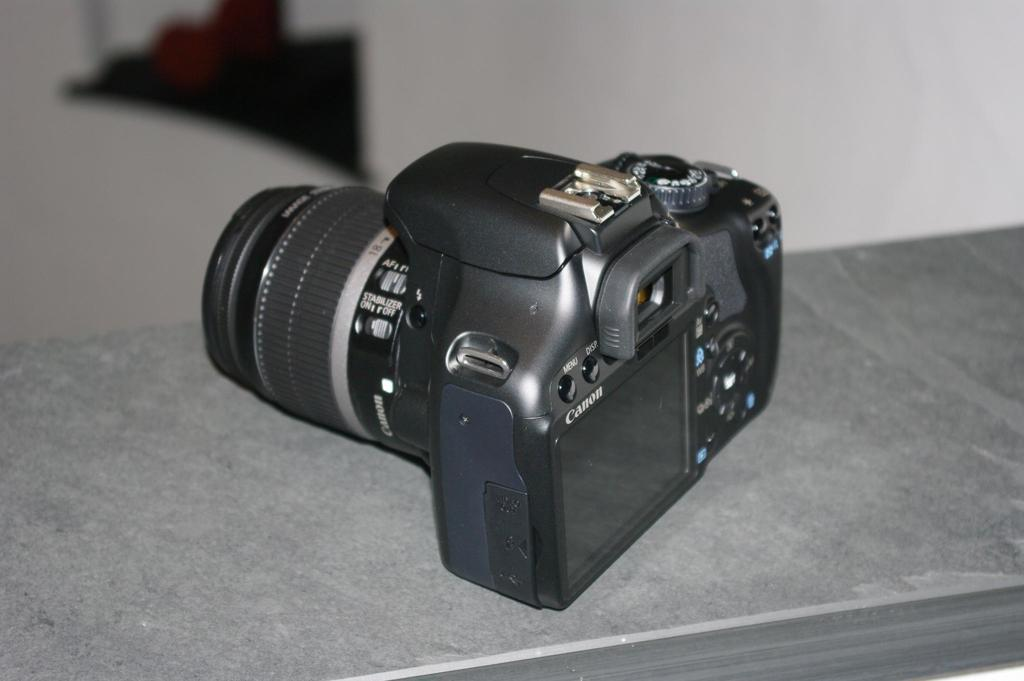What object is the main subject of the image? There is a camera in the image. What color is the camera? The camera is black in color. Are there any words or letters on the camera? Yes, there is text written on the camera. How many daughters can be seen working in the fields in the image? There are no daughters or fields present in the image; it features a black camera with text on it. 